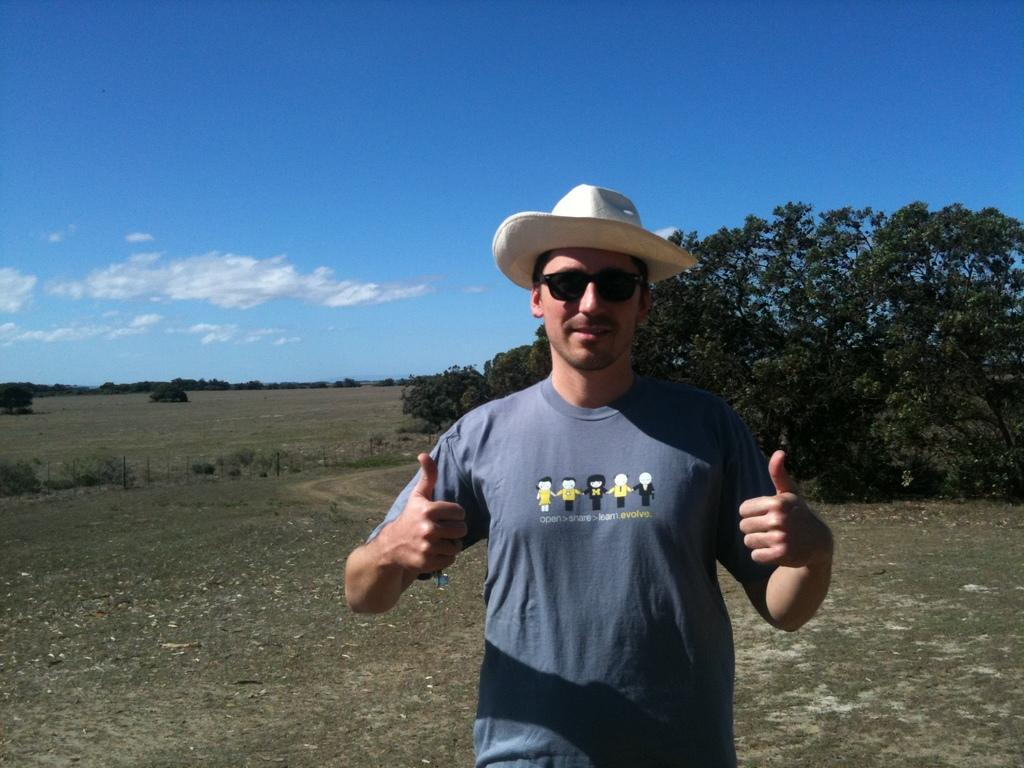What is the main subject of the image? There is a person in the image. What protective gear is the person wearing? The person is wearing goggles. What type of headwear is the person wearing? The person is wearing a hat. What is the facial expression of the person? The person is smiling. What type of vegetation can be seen in the background of the image? There are plants, grass, and trees in the background of the image. What architectural features are visible in the background of the image? There are poles in the background of the image. What part of the natural environment is visible in the background of the image? The sky is visible in the background of the image. What type of liquid is being poured on the person's head in the image? There is no liquid being poured on the person's head in the image. How does the earthquake affect the person in the image? There is no earthquake depicted in the image, so its effect on the person cannot be determined. 